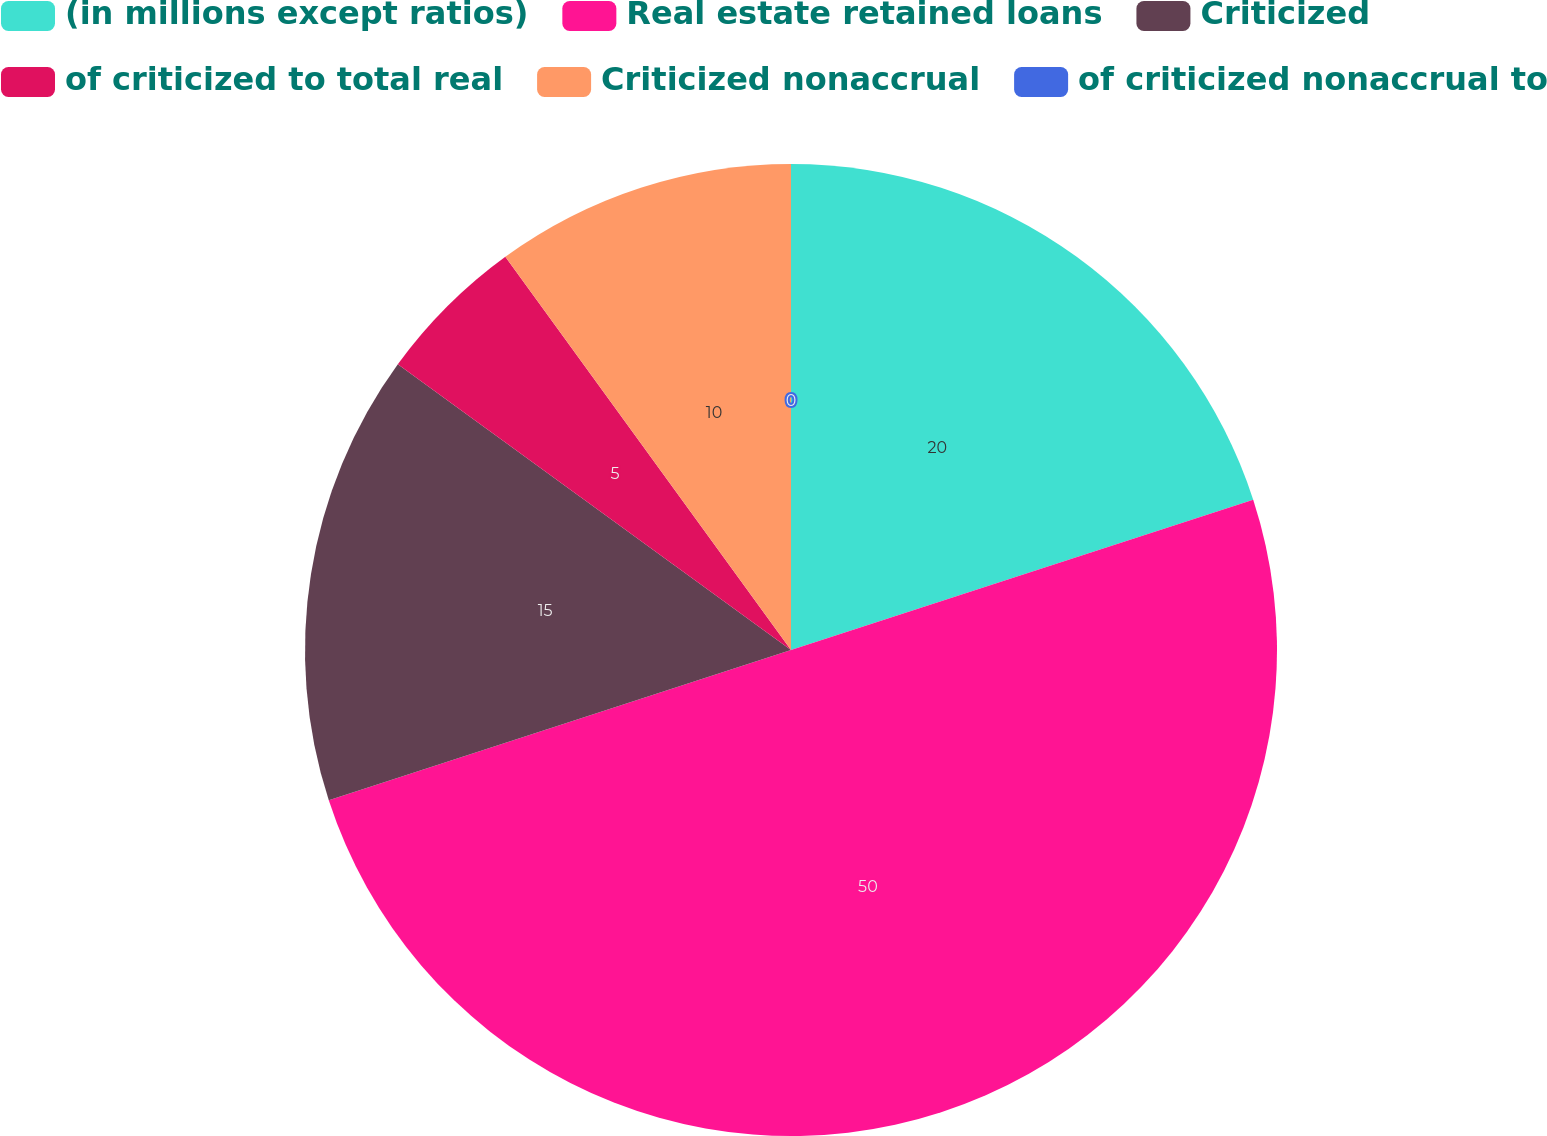Convert chart. <chart><loc_0><loc_0><loc_500><loc_500><pie_chart><fcel>(in millions except ratios)<fcel>Real estate retained loans<fcel>Criticized<fcel>of criticized to total real<fcel>Criticized nonaccrual<fcel>of criticized nonaccrual to<nl><fcel>20.0%<fcel>50.0%<fcel>15.0%<fcel>5.0%<fcel>10.0%<fcel>0.0%<nl></chart> 